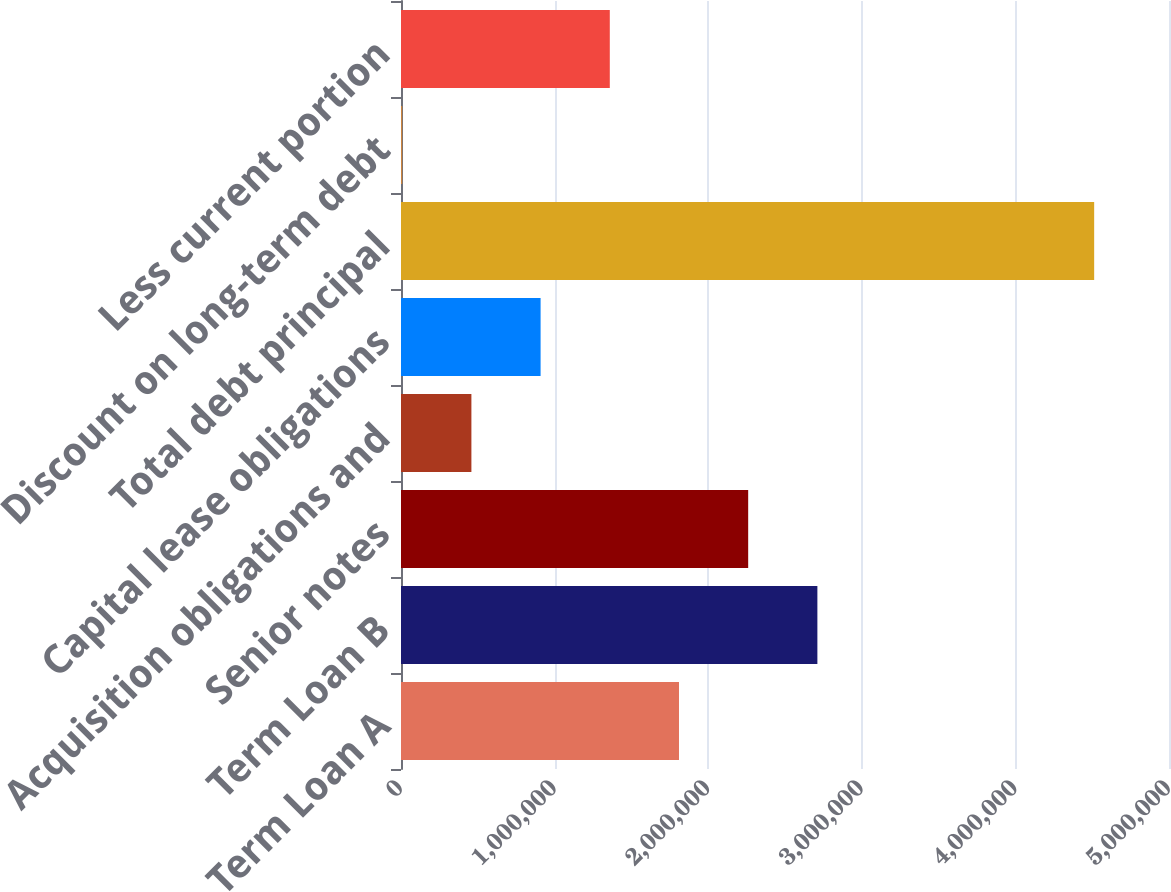<chart> <loc_0><loc_0><loc_500><loc_500><bar_chart><fcel>Term Loan A<fcel>Term Loan B<fcel>Senior notes<fcel>Acquisition obligations and<fcel>Capital lease obligations<fcel>Total debt principal<fcel>Discount on long-term debt<fcel>Less current portion<nl><fcel>1.80983e+06<fcel>2.71082e+06<fcel>2.26033e+06<fcel>458339<fcel>908836<fcel>4.51281e+06<fcel>7842<fcel>1.35933e+06<nl></chart> 